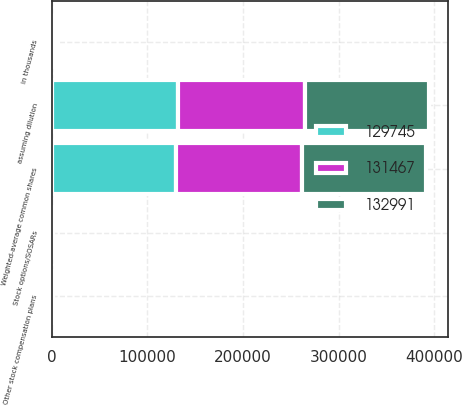<chart> <loc_0><loc_0><loc_500><loc_500><stacked_bar_chart><ecel><fcel>in thousands<fcel>Weighted-average common shares<fcel>Stock options/SOSARs<fcel>Other stock compensation plans<fcel>assuming dilution<nl><fcel>131467<fcel>2014<fcel>131461<fcel>656<fcel>874<fcel>132991<nl><fcel>129745<fcel>2013<fcel>130272<fcel>461<fcel>734<fcel>131467<nl><fcel>132991<fcel>2012<fcel>129745<fcel>0<fcel>0<fcel>129745<nl></chart> 